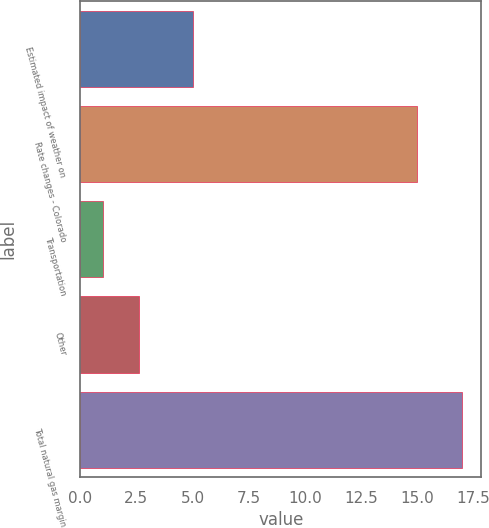<chart> <loc_0><loc_0><loc_500><loc_500><bar_chart><fcel>Estimated impact of weather on<fcel>Rate changes - Colorado<fcel>Transportation<fcel>Other<fcel>Total natural gas margin<nl><fcel>5<fcel>15<fcel>1<fcel>2.6<fcel>17<nl></chart> 